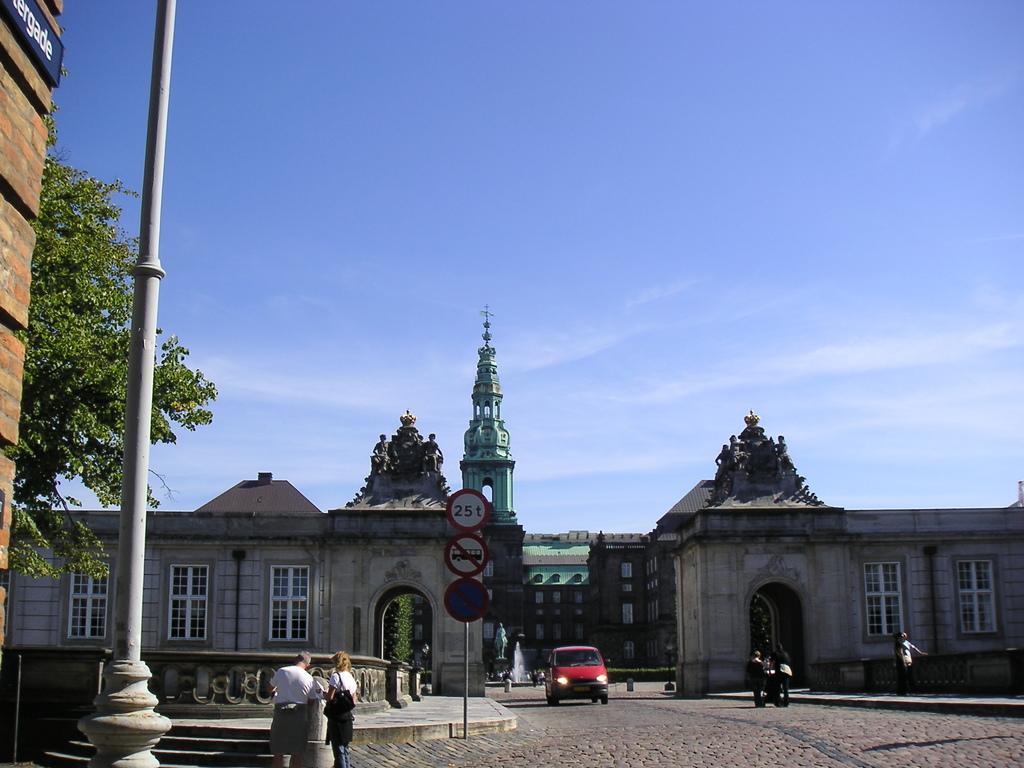Could you give a brief overview of what you see in this image? There is a pole, sign boards, vehicles, trees, people and buildings at the back. 